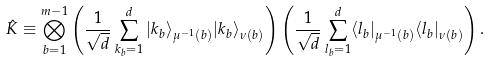<formula> <loc_0><loc_0><loc_500><loc_500>\hat { K } \equiv \bigotimes _ { b = 1 } ^ { m - 1 } \left ( \frac { 1 } { \sqrt { d } } \sum _ { k _ { b } = 1 } ^ { d } | k _ { b } \rangle _ { \mu ^ { - 1 } ( b ) } | k _ { b } \rangle _ { \nu ( b ) } \right ) \left ( \frac { 1 } { \sqrt { d } } \sum _ { l _ { b } = 1 } ^ { d } \langle l _ { b } | _ { \mu ^ { - 1 } ( b ) } \langle l _ { b } | _ { \nu ( b ) } \right ) .</formula> 